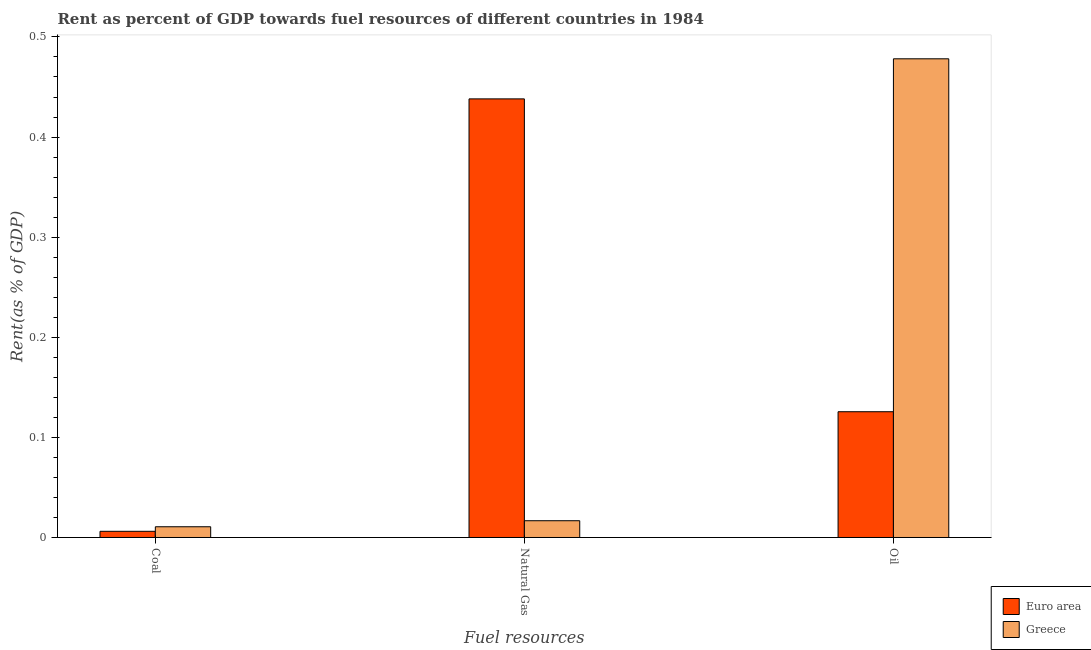How many different coloured bars are there?
Ensure brevity in your answer.  2. How many groups of bars are there?
Offer a terse response. 3. Are the number of bars per tick equal to the number of legend labels?
Offer a terse response. Yes. Are the number of bars on each tick of the X-axis equal?
Your response must be concise. Yes. How many bars are there on the 1st tick from the left?
Keep it short and to the point. 2. How many bars are there on the 1st tick from the right?
Make the answer very short. 2. What is the label of the 1st group of bars from the left?
Your answer should be very brief. Coal. What is the rent towards natural gas in Euro area?
Give a very brief answer. 0.44. Across all countries, what is the maximum rent towards natural gas?
Your answer should be very brief. 0.44. Across all countries, what is the minimum rent towards natural gas?
Offer a very short reply. 0.02. In which country was the rent towards natural gas maximum?
Give a very brief answer. Euro area. What is the total rent towards coal in the graph?
Ensure brevity in your answer.  0.02. What is the difference between the rent towards coal in Euro area and that in Greece?
Ensure brevity in your answer.  -0. What is the difference between the rent towards natural gas in Greece and the rent towards oil in Euro area?
Your answer should be compact. -0.11. What is the average rent towards coal per country?
Ensure brevity in your answer.  0.01. What is the difference between the rent towards oil and rent towards coal in Greece?
Your answer should be compact. 0.47. In how many countries, is the rent towards oil greater than 0.36000000000000004 %?
Provide a short and direct response. 1. What is the ratio of the rent towards oil in Greece to that in Euro area?
Your answer should be compact. 3.81. Is the difference between the rent towards natural gas in Greece and Euro area greater than the difference between the rent towards coal in Greece and Euro area?
Your answer should be very brief. No. What is the difference between the highest and the second highest rent towards natural gas?
Offer a terse response. 0.42. What is the difference between the highest and the lowest rent towards natural gas?
Ensure brevity in your answer.  0.42. What does the 2nd bar from the left in Oil represents?
Ensure brevity in your answer.  Greece. Is it the case that in every country, the sum of the rent towards coal and rent towards natural gas is greater than the rent towards oil?
Ensure brevity in your answer.  No. How many bars are there?
Make the answer very short. 6. Are all the bars in the graph horizontal?
Make the answer very short. No. What is the difference between two consecutive major ticks on the Y-axis?
Give a very brief answer. 0.1. Does the graph contain any zero values?
Keep it short and to the point. No. Does the graph contain grids?
Make the answer very short. No. Where does the legend appear in the graph?
Offer a terse response. Bottom right. How many legend labels are there?
Your answer should be very brief. 2. What is the title of the graph?
Give a very brief answer. Rent as percent of GDP towards fuel resources of different countries in 1984. Does "Uganda" appear as one of the legend labels in the graph?
Ensure brevity in your answer.  No. What is the label or title of the X-axis?
Provide a short and direct response. Fuel resources. What is the label or title of the Y-axis?
Offer a very short reply. Rent(as % of GDP). What is the Rent(as % of GDP) in Euro area in Coal?
Keep it short and to the point. 0.01. What is the Rent(as % of GDP) of Greece in Coal?
Provide a short and direct response. 0.01. What is the Rent(as % of GDP) in Euro area in Natural Gas?
Your answer should be compact. 0.44. What is the Rent(as % of GDP) of Greece in Natural Gas?
Your answer should be very brief. 0.02. What is the Rent(as % of GDP) in Euro area in Oil?
Your answer should be very brief. 0.13. What is the Rent(as % of GDP) in Greece in Oil?
Ensure brevity in your answer.  0.48. Across all Fuel resources, what is the maximum Rent(as % of GDP) of Euro area?
Offer a very short reply. 0.44. Across all Fuel resources, what is the maximum Rent(as % of GDP) of Greece?
Give a very brief answer. 0.48. Across all Fuel resources, what is the minimum Rent(as % of GDP) in Euro area?
Your answer should be very brief. 0.01. Across all Fuel resources, what is the minimum Rent(as % of GDP) of Greece?
Give a very brief answer. 0.01. What is the total Rent(as % of GDP) of Euro area in the graph?
Your answer should be very brief. 0.57. What is the total Rent(as % of GDP) in Greece in the graph?
Ensure brevity in your answer.  0.51. What is the difference between the Rent(as % of GDP) in Euro area in Coal and that in Natural Gas?
Provide a short and direct response. -0.43. What is the difference between the Rent(as % of GDP) of Greece in Coal and that in Natural Gas?
Provide a succinct answer. -0.01. What is the difference between the Rent(as % of GDP) in Euro area in Coal and that in Oil?
Your answer should be very brief. -0.12. What is the difference between the Rent(as % of GDP) of Greece in Coal and that in Oil?
Ensure brevity in your answer.  -0.47. What is the difference between the Rent(as % of GDP) of Euro area in Natural Gas and that in Oil?
Your answer should be very brief. 0.31. What is the difference between the Rent(as % of GDP) of Greece in Natural Gas and that in Oil?
Give a very brief answer. -0.46. What is the difference between the Rent(as % of GDP) of Euro area in Coal and the Rent(as % of GDP) of Greece in Natural Gas?
Offer a terse response. -0.01. What is the difference between the Rent(as % of GDP) of Euro area in Coal and the Rent(as % of GDP) of Greece in Oil?
Keep it short and to the point. -0.47. What is the difference between the Rent(as % of GDP) of Euro area in Natural Gas and the Rent(as % of GDP) of Greece in Oil?
Your answer should be very brief. -0.04. What is the average Rent(as % of GDP) in Euro area per Fuel resources?
Keep it short and to the point. 0.19. What is the average Rent(as % of GDP) of Greece per Fuel resources?
Give a very brief answer. 0.17. What is the difference between the Rent(as % of GDP) in Euro area and Rent(as % of GDP) in Greece in Coal?
Offer a very short reply. -0. What is the difference between the Rent(as % of GDP) in Euro area and Rent(as % of GDP) in Greece in Natural Gas?
Your answer should be compact. 0.42. What is the difference between the Rent(as % of GDP) of Euro area and Rent(as % of GDP) of Greece in Oil?
Make the answer very short. -0.35. What is the ratio of the Rent(as % of GDP) in Euro area in Coal to that in Natural Gas?
Offer a very short reply. 0.01. What is the ratio of the Rent(as % of GDP) in Greece in Coal to that in Natural Gas?
Give a very brief answer. 0.64. What is the ratio of the Rent(as % of GDP) in Euro area in Coal to that in Oil?
Offer a terse response. 0.05. What is the ratio of the Rent(as % of GDP) of Greece in Coal to that in Oil?
Offer a very short reply. 0.02. What is the ratio of the Rent(as % of GDP) of Euro area in Natural Gas to that in Oil?
Ensure brevity in your answer.  3.49. What is the ratio of the Rent(as % of GDP) of Greece in Natural Gas to that in Oil?
Offer a terse response. 0.04. What is the difference between the highest and the second highest Rent(as % of GDP) in Euro area?
Offer a terse response. 0.31. What is the difference between the highest and the second highest Rent(as % of GDP) of Greece?
Your answer should be very brief. 0.46. What is the difference between the highest and the lowest Rent(as % of GDP) of Euro area?
Provide a succinct answer. 0.43. What is the difference between the highest and the lowest Rent(as % of GDP) in Greece?
Make the answer very short. 0.47. 